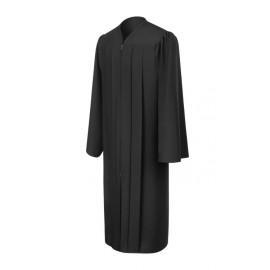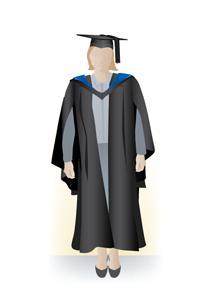The first image is the image on the left, the second image is the image on the right. Given the left and right images, does the statement "An image shows a black graduation robe with bright blue around the collar, and the other image shows an unworn solid-colored gown." hold true? Answer yes or no. Yes. 